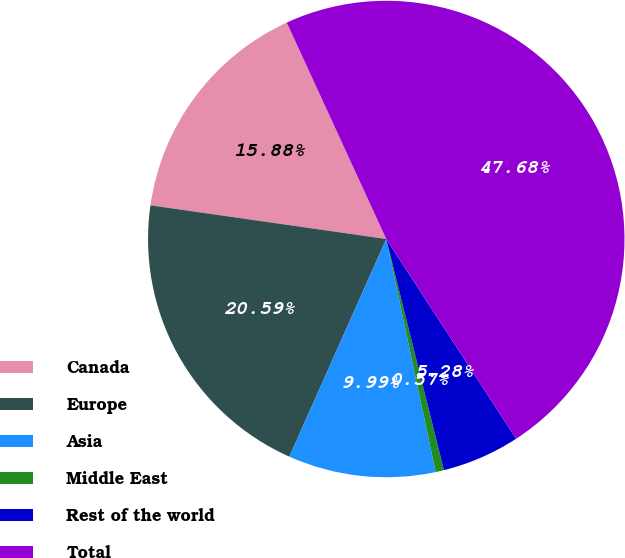Convert chart to OTSL. <chart><loc_0><loc_0><loc_500><loc_500><pie_chart><fcel>Canada<fcel>Europe<fcel>Asia<fcel>Middle East<fcel>Rest of the world<fcel>Total<nl><fcel>15.88%<fcel>20.59%<fcel>9.99%<fcel>0.57%<fcel>5.28%<fcel>47.68%<nl></chart> 